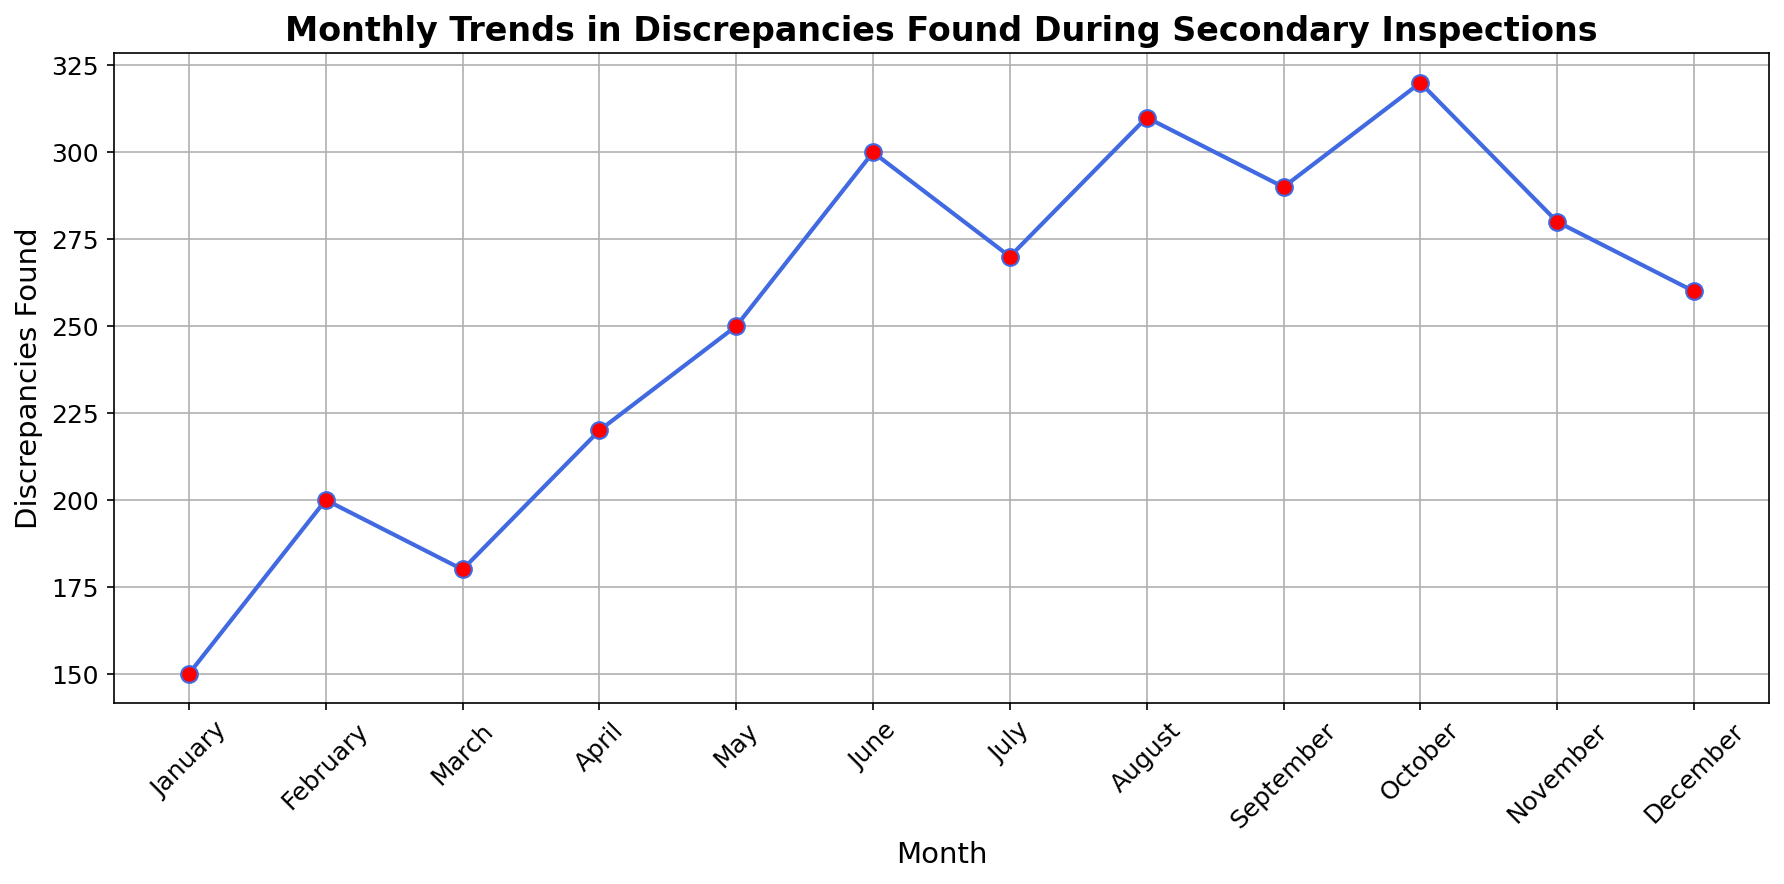What is the month with the highest number of discrepancies found? The figure shows that the month with the highest peak among all points is October, reaching the highest value in the plot.
Answer: October How many discrepancies were found in March compared to May? Referring to the figure, March shows 180 discrepancies, and May shows 250 discrepancies. Calculating the difference: 250 - 180 = 70.
Answer: March has 70 fewer discrepancies than May Which month shows the largest increase in discrepancies? By observing the plotted points, the largest increase occurs from May (250) to June (300). The difference can be calculated as 300 - 250 = 50.
Answer: May to June What is the average number of discrepancies found in January, February, and March? Referring to the figure, the values for January, February, and March are 150, 200, and 180 respectively. The sum is 150 + 200 + 180 = 530. Average is 530 / 3 = 176.67.
Answer: 176.67 Is there any month where discrepancies decrease compared to the previous month? By closely looking at the plot, discrepancies from August (310) to September (290) decrease, and from October (320) to November (280) decrease as well.
Answer: Yes, between August-September and October-November What is the trend in discrepancies from April to July? Observing the figure from April to July: April has 220, May has 250, June has 300, and July has 270. The trend shows a rise from April (220) to May (250) to June (300) followed by a decrease in July (270).
Answer: Rising then falling How many discrepancies were found altogether in the first half of the year (January to June)? Adding up the values in the figure for each month from January to June: 150 + 200 + 180 + 220 + 250 + 300 = 1300.
Answer: 1300 What is the median number of discrepancies found over the entire year? List out all the values in ascending order: 150, 180, 200, 220, 250, 260, 270, 280, 290, 300, 310, 320. Median will be the average of the 6th and 7th values: (260 + 270) / 2 = 265.
Answer: 265 